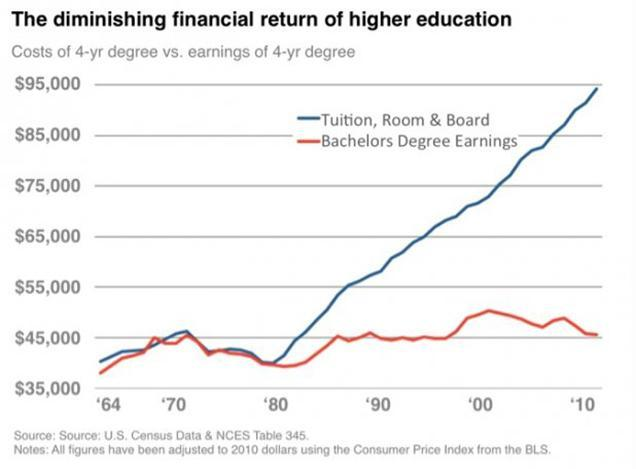According to the graph, which parameter has increased upto $95,000?
Answer the question with a short phrase. Tuition, Room & Board Under what category does Tuition, Room & Board come? Costs of 4-yr degree What parameter is shown using the red line on the graph? Bachelors Degree Earnings By what coloured line is Tuition, Room & Board represented on the graph- red, blue or green? blue 